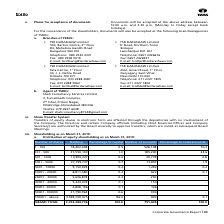According to Tata Consultancy Services's financial document, What is the number of existing shareholding accounts as on March 31, 2019?   According to the financial document, 751,605. The relevant text states: "GRAND TOTAL 3,752,384,706 100.0 751,605 100.0..." Also, What is the grand total of holdings as on March 31, 2019? According to the financial document, 3,752,384,706. The relevant text states: "GRAND TOTAL 3,752,384,706 100.0 751,605 100.0..." Also, How many accounts hold 100001 and above number of shares? According to the financial document, 903. The relevant text states: "100001 - above 3,598,709,075 96.0 903 0.1..." Additionally, Which category of shares have the highest number of holdings? According to the financial document, 100001 - above. The relevant text states: "100001 - above 3,598,709,075 96.0 903 0.1..." Also, can you calculate: What is the difference in number of accounts between the share categories of '1-100' and '101-500'? Based on the calculation: 528,148-185,200, the result is 342948. This is based on the information: "1 - 100 18,402,438 0.5 528,148 70.3 101 - 500 37,550,103 1.0 185,200 24.6..." The key data points involved are: 185,200, 528,148. Also, can you calculate: What is the difference in holdings between the share categories of '1-100' and '101-500'? Based on the calculation: 37,550,103-18,402,438, the result is 19147665. This is based on the information: "101 - 500 37,550,103 1.0 185,200 24.6 1 - 100 18,402,438 0.5 528,148 70.3..." The key data points involved are: 18,402,438, 37,550,103. 